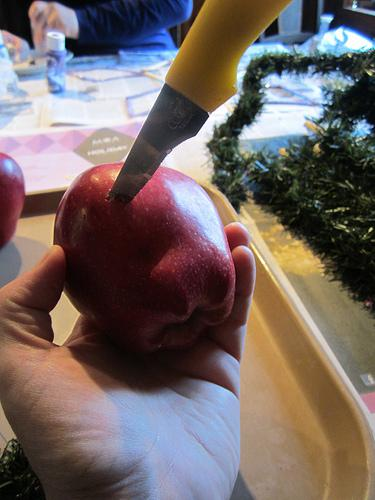Question: who is cutting the fruit?
Choices:
A. The chef.
B. The person.
C. The cook.
D. The woman.
Answer with the letter. Answer: B Question: what fruit is this?
Choices:
A. Apple.
B. Pear.
C. Mango.
D. Kiwi.
Answer with the letter. Answer: A Question: how many apples are there?
Choices:
A. Three.
B. Two.
C. Five.
D. Four.
Answer with the letter. Answer: B 